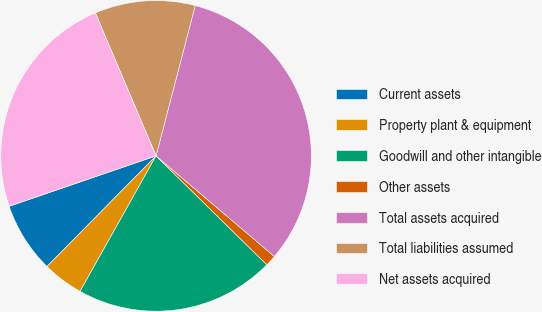Convert chart. <chart><loc_0><loc_0><loc_500><loc_500><pie_chart><fcel>Current assets<fcel>Property plant & equipment<fcel>Goodwill and other intangible<fcel>Other assets<fcel>Total assets acquired<fcel>Total liabilities assumed<fcel>Net assets acquired<nl><fcel>7.35%<fcel>4.25%<fcel>20.77%<fcel>1.15%<fcel>32.15%<fcel>10.45%<fcel>23.87%<nl></chart> 